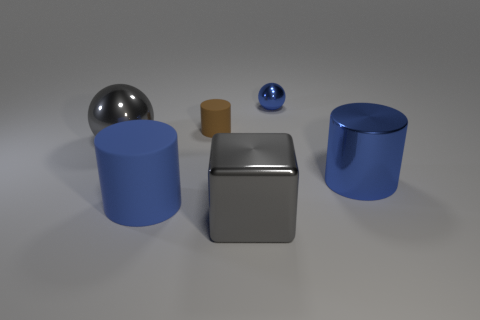Is the color of the big block the same as the big shiny sphere?
Keep it short and to the point. Yes. There is a metal object that is the same color as the metallic cylinder; what size is it?
Your response must be concise. Small. Are there any large brown blocks that have the same material as the tiny blue sphere?
Your answer should be compact. No. What is the color of the matte cylinder that is in front of the blue cylinder that is to the right of the small thing left of the tiny metal ball?
Offer a very short reply. Blue. How many purple objects are large metallic blocks or metal balls?
Provide a short and direct response. 0. How many other rubber things have the same shape as the small matte thing?
Give a very brief answer. 1. What shape is the blue metal object that is the same size as the gray cube?
Ensure brevity in your answer.  Cylinder. Are there any big blue objects in front of the large blue rubber cylinder?
Provide a short and direct response. No. Are there any large shiny spheres that are left of the big metal cylinder that is behind the large matte thing?
Give a very brief answer. Yes. Is the number of small shiny spheres that are behind the blue metallic ball less than the number of big gray spheres to the right of the big rubber cylinder?
Give a very brief answer. No. 